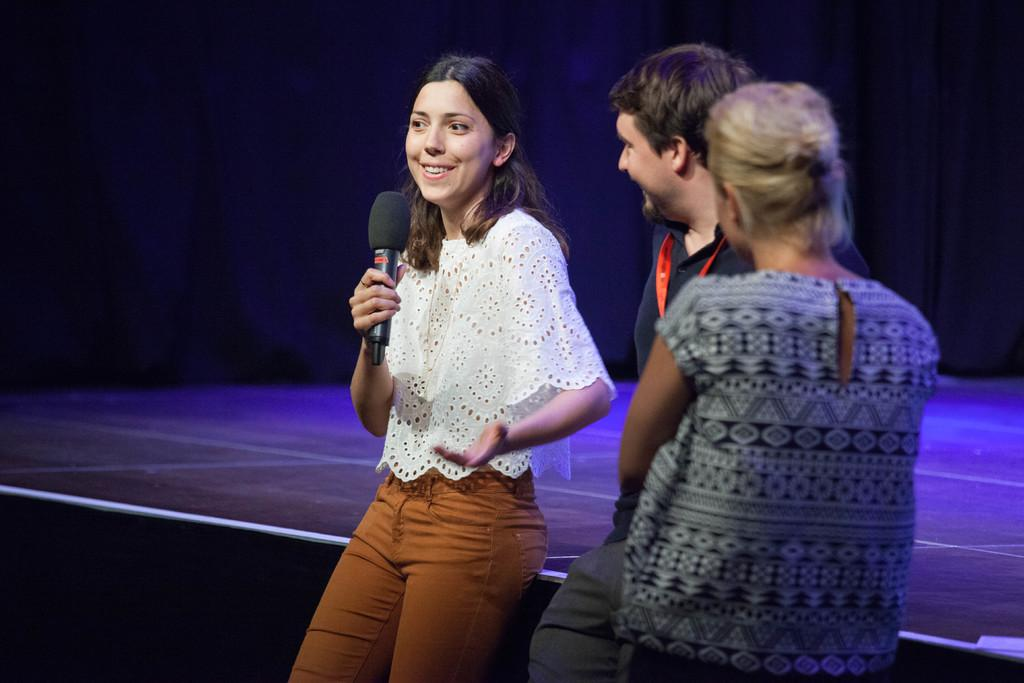How many people are in the image? There are three persons standing in the image. What is the woman holding in the image? The woman is holding a microphone. What is the expression on the woman's face? The woman is smiling. What can be seen in the background of the image? There is a stage in the background. How would you describe the lighting in the image? The background is dark. What type of mine is visible in the background of the image? There is no mine present in the image; it features a stage in the background. Can you list the types of bushes that can be seen in the image? There are no bushes present in the image. 